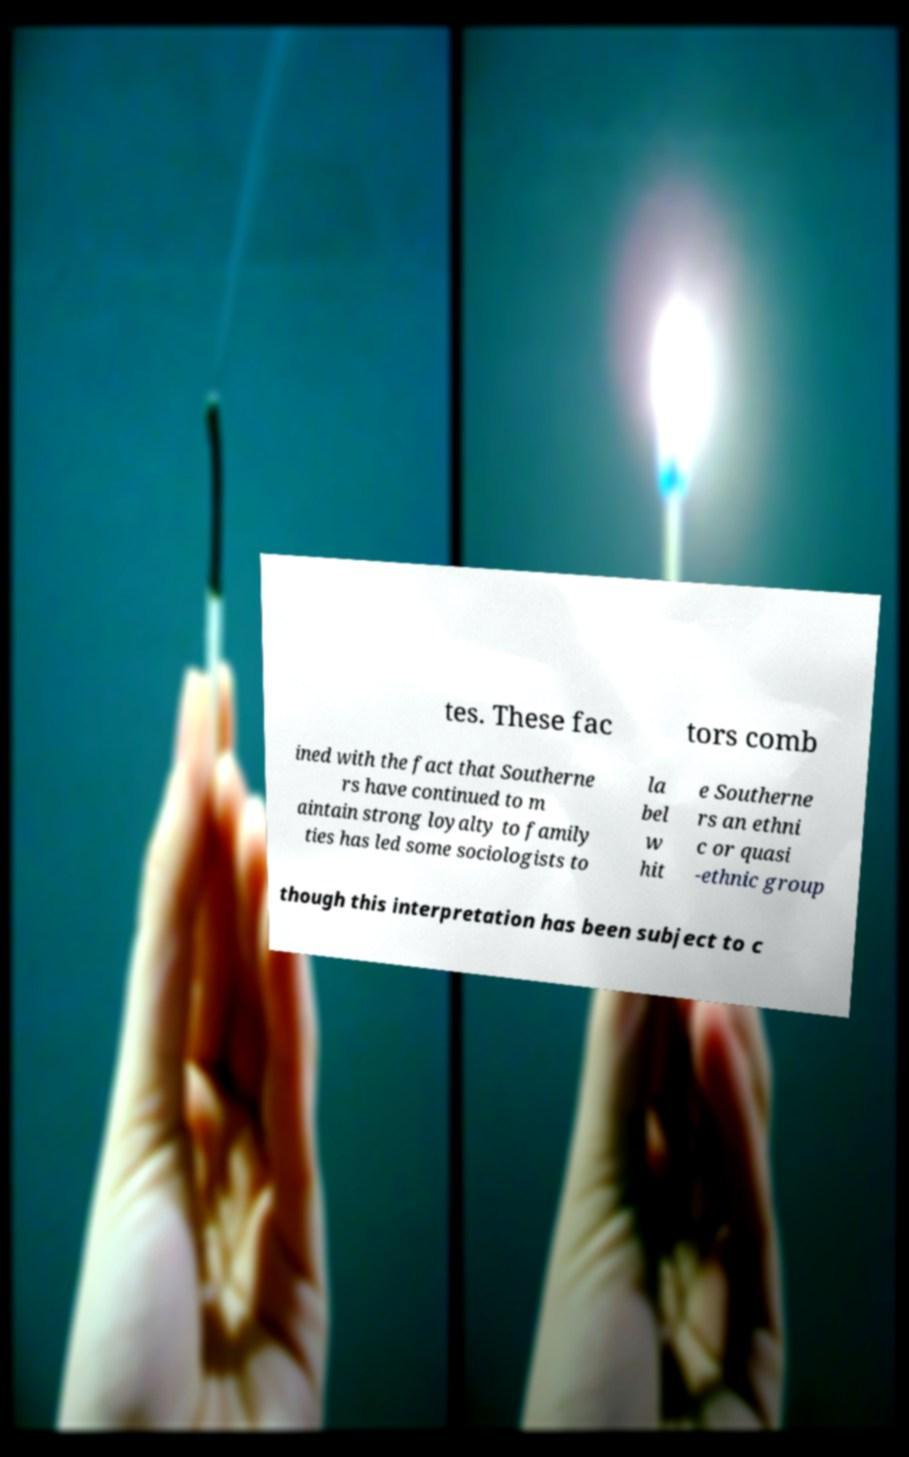Could you assist in decoding the text presented in this image and type it out clearly? tes. These fac tors comb ined with the fact that Southerne rs have continued to m aintain strong loyalty to family ties has led some sociologists to la bel w hit e Southerne rs an ethni c or quasi -ethnic group though this interpretation has been subject to c 